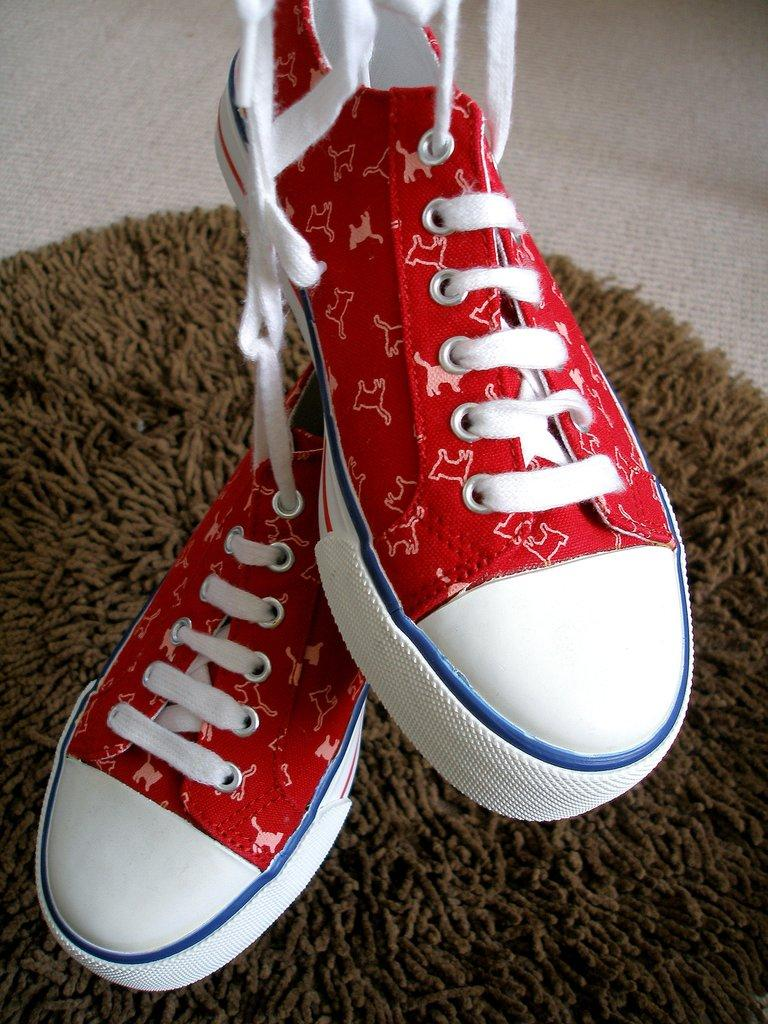What type of footwear is visible in the image? There are shoes in the image. What is on the floor in the image? There is a mat on the floor in the image. What type of stove is present in the image? There is no stove present in the image; it only features shoes and a mat. What type of pleasure can be seen being experienced by the shoes in the image? Shoes do not experience pleasure, and there is no indication of pleasure in the image. 